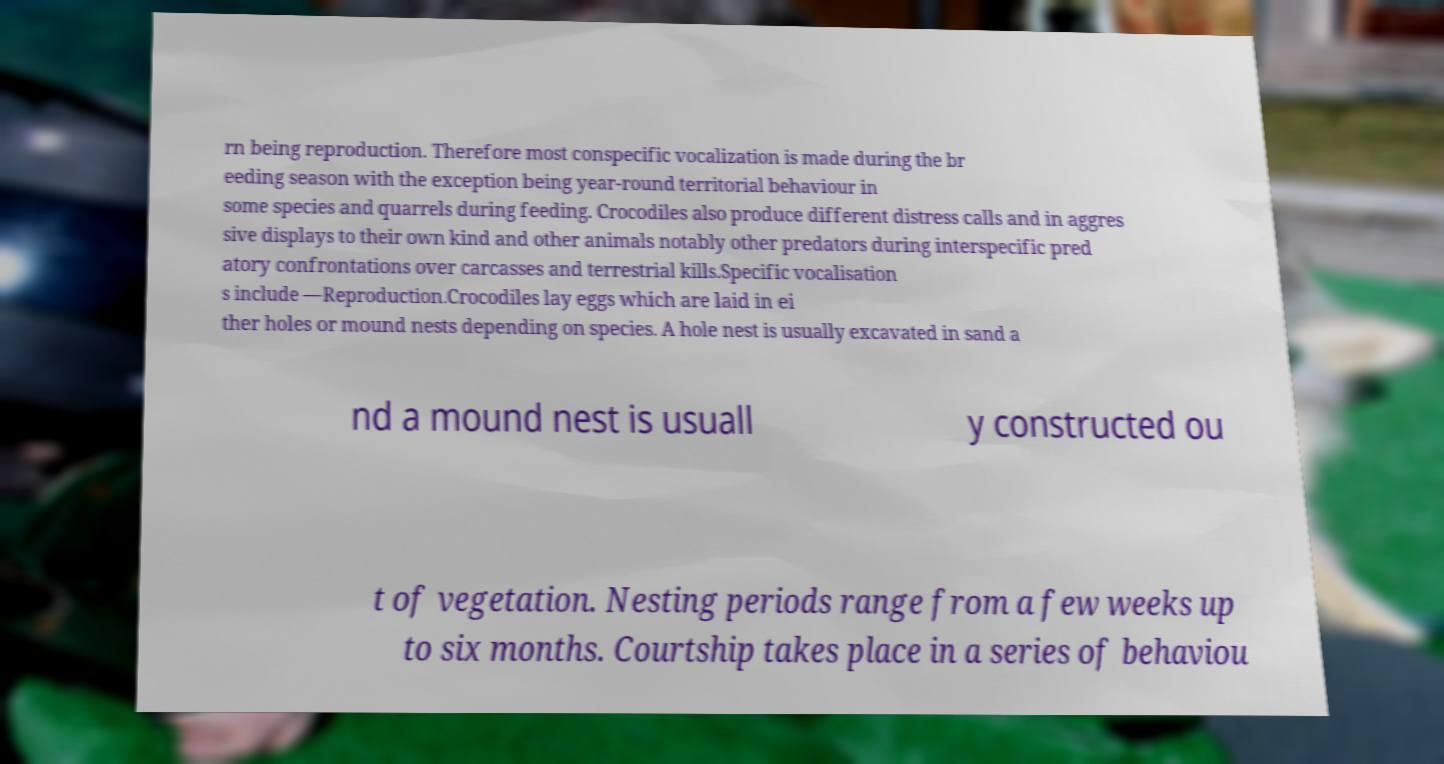Please identify and transcribe the text found in this image. rn being reproduction. Therefore most conspecific vocalization is made during the br eeding season with the exception being year-round territorial behaviour in some species and quarrels during feeding. Crocodiles also produce different distress calls and in aggres sive displays to their own kind and other animals notably other predators during interspecific pred atory confrontations over carcasses and terrestrial kills.Specific vocalisation s include —Reproduction.Crocodiles lay eggs which are laid in ei ther holes or mound nests depending on species. A hole nest is usually excavated in sand a nd a mound nest is usuall y constructed ou t of vegetation. Nesting periods range from a few weeks up to six months. Courtship takes place in a series of behaviou 